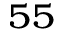<formula> <loc_0><loc_0><loc_500><loc_500>^ { 5 5 }</formula> 